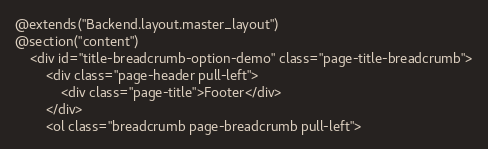Convert code to text. <code><loc_0><loc_0><loc_500><loc_500><_PHP_>@extends("Backend.layout.master_layout")
@section("content")
    <div id="title-breadcrumb-option-demo" class="page-title-breadcrumb">
        <div class="page-header pull-left">
            <div class="page-title">Footer</div>
        </div>
        <ol class="breadcrumb page-breadcrumb pull-left"></code> 